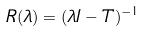<formula> <loc_0><loc_0><loc_500><loc_500>R ( \lambda ) = ( \lambda I - T ) ^ { - 1 }</formula> 